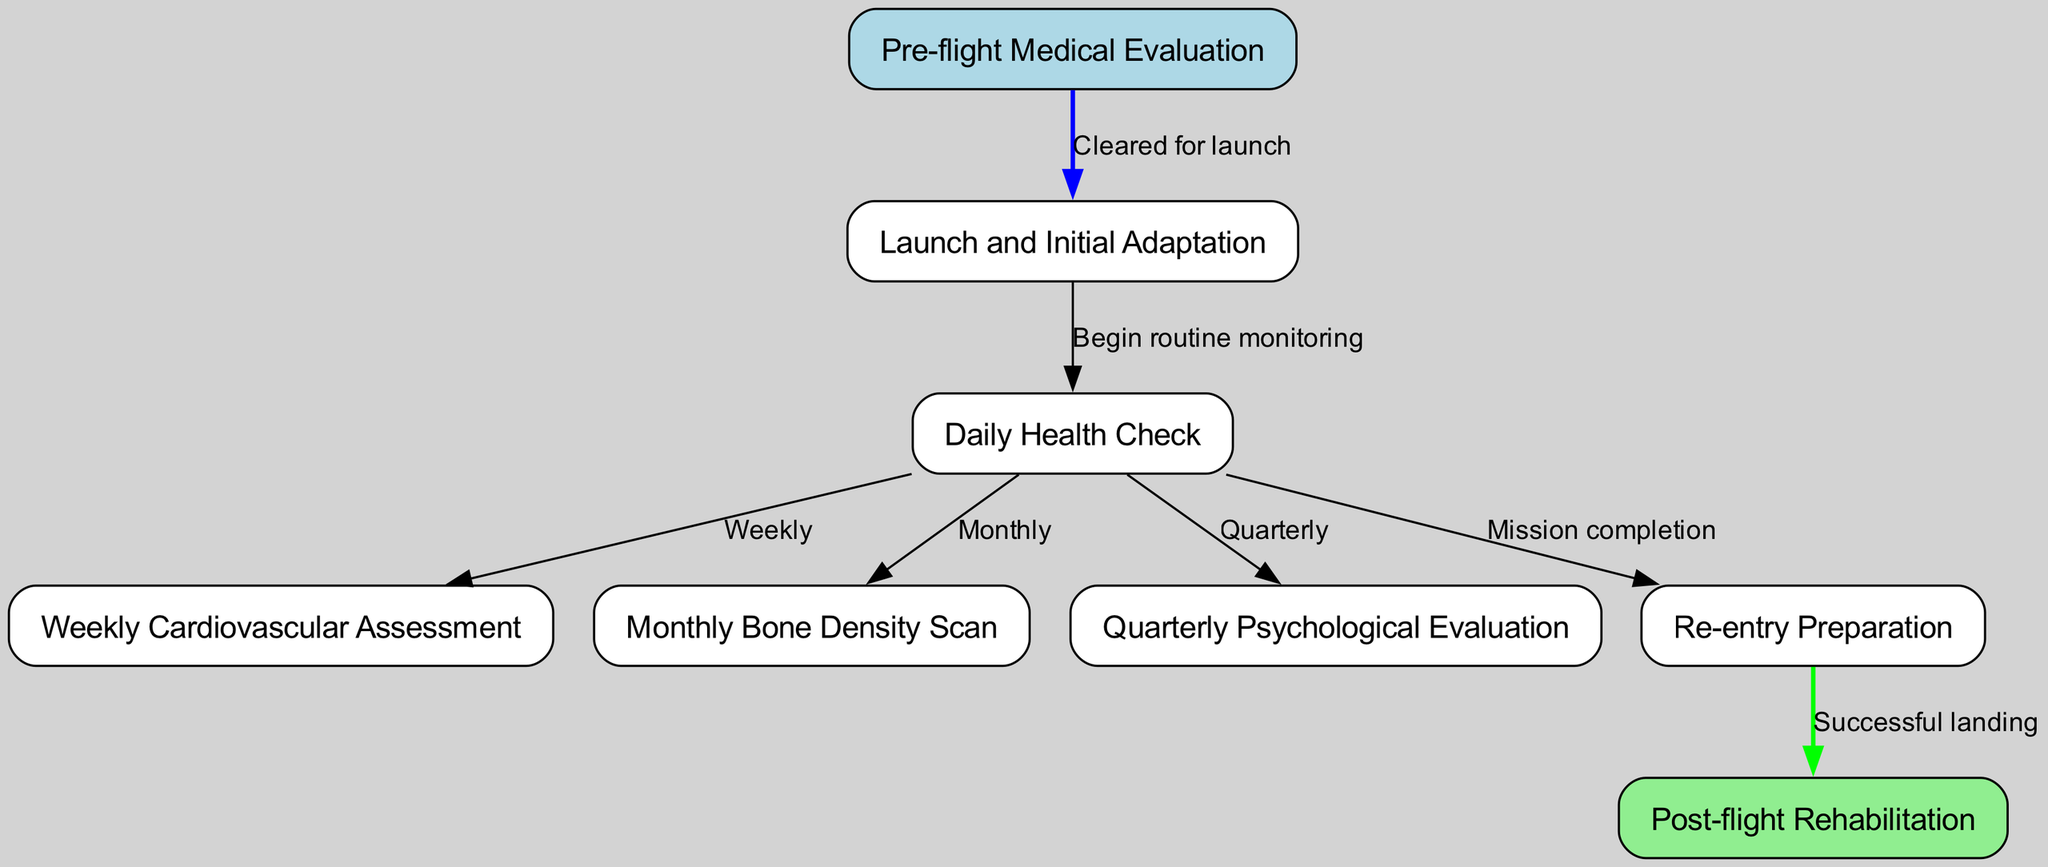What is the first step in the astronaut health monitoring protocol? The first step is labeled as "Pre-flight Medical Evaluation," which is the initial assessment before launching.
Answer: Pre-flight Medical Evaluation How many health assessment types are there after initial adaptation? After the "Launch and Initial Adaptation," there are four distinct types of health assessments, namely Daily Health Check, Weekly Cardiovascular Assessment, Monthly Bone Density Scan, and Quarterly Psychological Evaluation.
Answer: Four What is monitored weekly during the mission? The diagram specifies that a "Weekly Cardiovascular Assessment" is conducted, indicating that cardiovascular health is tracked on a weekly basis.
Answer: Weekly Cardiovascular Assessment What happens after the re-entry preparation? According to the diagram, after the "Re-entry Preparation," the next step described is "Post-flight Rehabilitation," which is crucial for recovery after the mission.
Answer: Post-flight Rehabilitation What triggers the transition from daily health checks to re-entry preparation? The transition occurs after completing all necessary monitoring and checks, which culminates in a label stating "Mission completion," leading to "Re-entry Preparation."
Answer: Mission completion How often are psychological evaluations conducted? The diagram indicates that "Quarterly Psychological Evaluation" occurs, denoting that this evaluation happens every three months or four times a year.
Answer: Quarterly How many connections are there from the Daily Health Check node? From the "Daily Health Check" node, there are four connections leading to Weekly Cardiovascular Assessment, Monthly Bone Density Scan, Quarterly Psychological Evaluation, and Re-entry Preparation.
Answer: Four What color is the node representing Post-flight Rehabilitation? The node for "Post-flight Rehabilitation" is colored light green, distinguishing it from the other health assessments in the diagram.
Answer: Light green What indicates that an astronaut is cleared for launch? The connectivity shows that once the "Pre-flight Medical Evaluation" is completed and approved, it suggests that the astronaut is "Cleared for launch."
Answer: Cleared for launch 